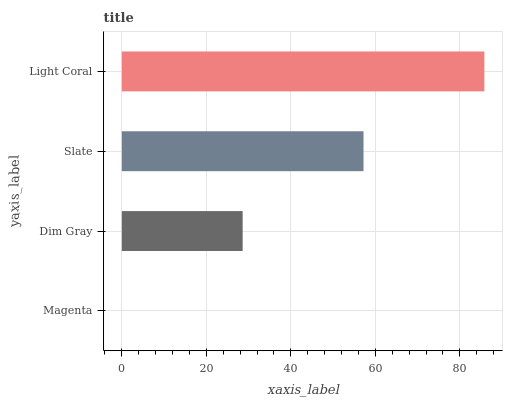Is Magenta the minimum?
Answer yes or no. Yes. Is Light Coral the maximum?
Answer yes or no. Yes. Is Dim Gray the minimum?
Answer yes or no. No. Is Dim Gray the maximum?
Answer yes or no. No. Is Dim Gray greater than Magenta?
Answer yes or no. Yes. Is Magenta less than Dim Gray?
Answer yes or no. Yes. Is Magenta greater than Dim Gray?
Answer yes or no. No. Is Dim Gray less than Magenta?
Answer yes or no. No. Is Slate the high median?
Answer yes or no. Yes. Is Dim Gray the low median?
Answer yes or no. Yes. Is Dim Gray the high median?
Answer yes or no. No. Is Slate the low median?
Answer yes or no. No. 